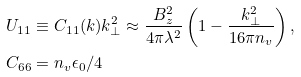<formula> <loc_0><loc_0><loc_500><loc_500>U _ { 1 1 } & \equiv C _ { 1 1 } ( k ) k _ { \perp } ^ { 2 } \approx \frac { B _ { z } ^ { 2 } } { 4 \pi \lambda ^ { 2 } } \left ( 1 - \frac { k _ { \perp } ^ { 2 } } { 1 6 \pi n _ { v } } \right ) , \\ C _ { 6 6 } & = n _ { v } \epsilon _ { 0 } / 4</formula> 